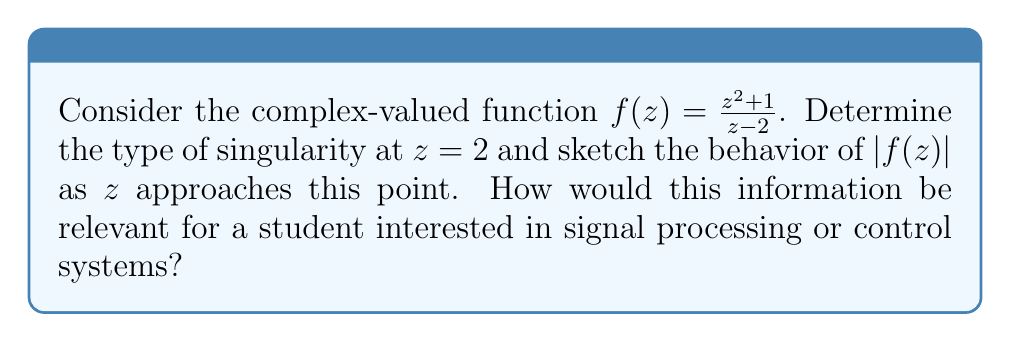Show me your answer to this math problem. Let's approach this step-by-step:

1) First, we need to identify the singularity. The function $f(z) = \frac{z^2+1}{z-2}$ has a singularity at $z=2$ because the denominator becomes zero at this point.

2) To determine the type of singularity, we need to examine the Laurent series expansion of $f(z)$ around $z=2$. Let's rewrite the function:

   $$f(z) = \frac{z^2+1}{z-2} = \frac{(z-2+2)^2+1}{z-2} = \frac{(z-2)^2+4(z-2)+5}{z-2}$$

3) Simplifying:
   
   $$f(z) = (z-2) + 4 + \frac{5}{z-2}$$

4) This is the Laurent series of $f(z)$ around $z=2$. We can see that there's a term with $(z-2)^{-1}$, but no terms with higher negative powers.

5) The presence of the $(z-2)^{-1}$ term and the absence of higher negative powers indicates that $z=2$ is a simple pole of $f(z)$.

6) For the behavior of $|f(z)|$ as $z$ approaches 2:
   
   $$\lim_{z \to 2} |f(z)| = \lim_{z \to 2} \left|\frac{5}{z-2} + 4 + (z-2)\right| = \infty$$

   This means that $|f(z)|$ grows without bound as $z$ approaches 2.

7) A sketch of $|f(z)|$ near $z=2$ would show a sharp peak approaching infinity at $z=2$.

[asy]
import graph;
size(200,200);
real f(real x, real y) {
  pair z = (x,y);
  return abs((z^2+1)/(z-2));
}
draw(contour(f,(-1,-1),(3,3),new real[]{1,2,3,4,5,10,20,50}));
dot((2,0),red);
label("z=2",(2,0),SE,red);
xaxis("Re(z)",Arrow);
yaxis("Im(z)",Arrow);
[/asy]

8) Relevance for signal processing or control systems:
   - In signal processing, poles represent resonances or sustained oscillations in systems.
   - In control systems, poles determine system stability and response characteristics.
   - Understanding the behavior near singularities helps in analyzing system stability, designing filters, and predicting system responses to various inputs.
Answer: Simple pole at $z=2$; $|f(z)| \to \infty$ as $z \to 2$ 